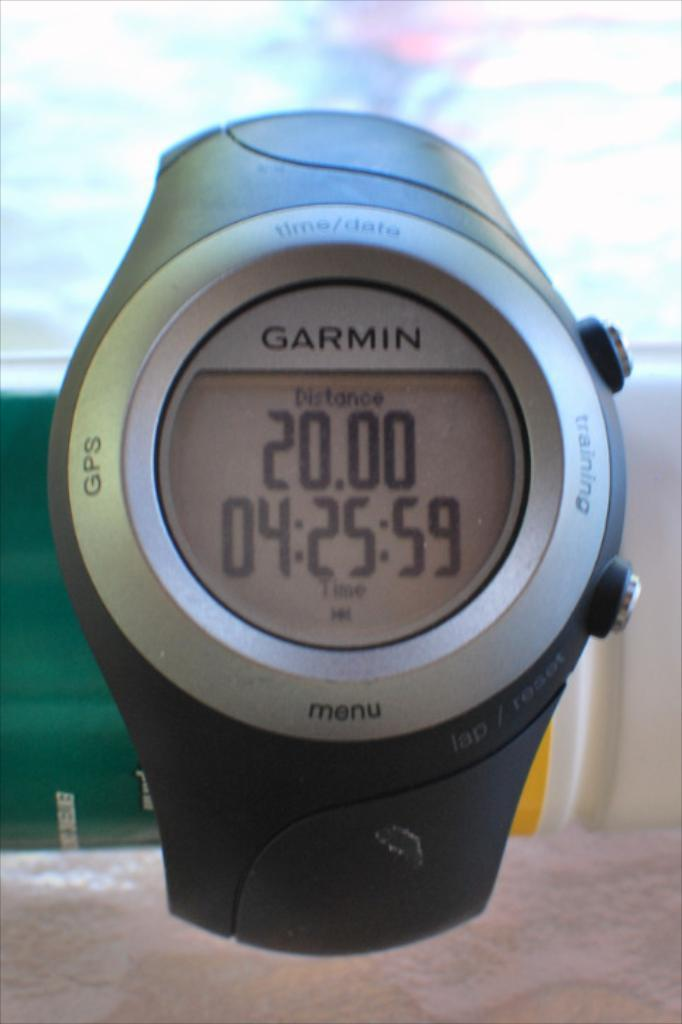<image>
Write a terse but informative summary of the picture. A garmin GPS watch showing a distance of 20.00 and a time of 04:25:59. 